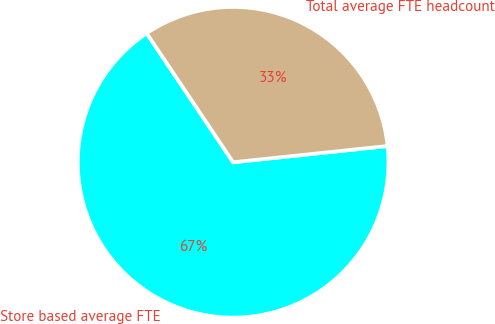Convert chart to OTSL. <chart><loc_0><loc_0><loc_500><loc_500><pie_chart><fcel>Store based average FTE<fcel>Total average FTE headcount<nl><fcel>67.27%<fcel>32.73%<nl></chart> 